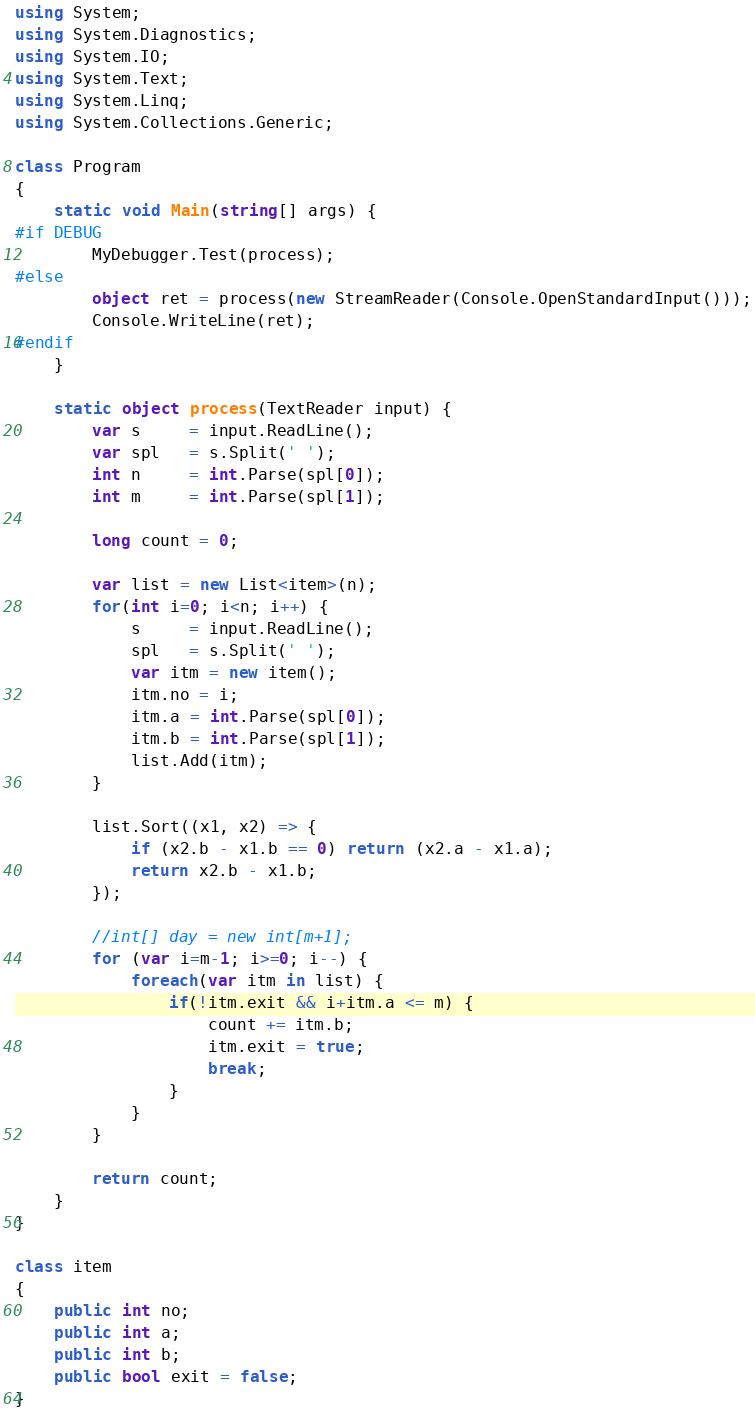<code> <loc_0><loc_0><loc_500><loc_500><_C#_>using System;
using System.Diagnostics;
using System.IO;
using System.Text;
using System.Linq;
using System.Collections.Generic;

class Program
{
    static void Main(string[] args) {
#if DEBUG
        MyDebugger.Test(process);
#else
        object ret = process(new StreamReader(Console.OpenStandardInput()));
        Console.WriteLine(ret);
#endif
    }

    static object process(TextReader input) {
        var s     = input.ReadLine();
        var spl   = s.Split(' ');
        int n     = int.Parse(spl[0]);
        int m     = int.Parse(spl[1]);

        long count = 0;

        var list = new List<item>(n);
        for(int i=0; i<n; i++) {
            s     = input.ReadLine();
            spl   = s.Split(' ');
            var itm = new item();
            itm.no = i;
            itm.a = int.Parse(spl[0]);
            itm.b = int.Parse(spl[1]);
            list.Add(itm);
        }

        list.Sort((x1, x2) => {
            if (x2.b - x1.b == 0) return (x2.a - x1.a);
            return x2.b - x1.b;
        });

        //int[] day = new int[m+1];
        for (var i=m-1; i>=0; i--) {
            foreach(var itm in list) {
                if(!itm.exit && i+itm.a <= m) {
                    count += itm.b;
                    itm.exit = true;
                    break;
                }
            }
        }

        return count;
    }
}

class item
{
    public int no;
    public int a;
    public int b;
    public bool exit = false;
}</code> 